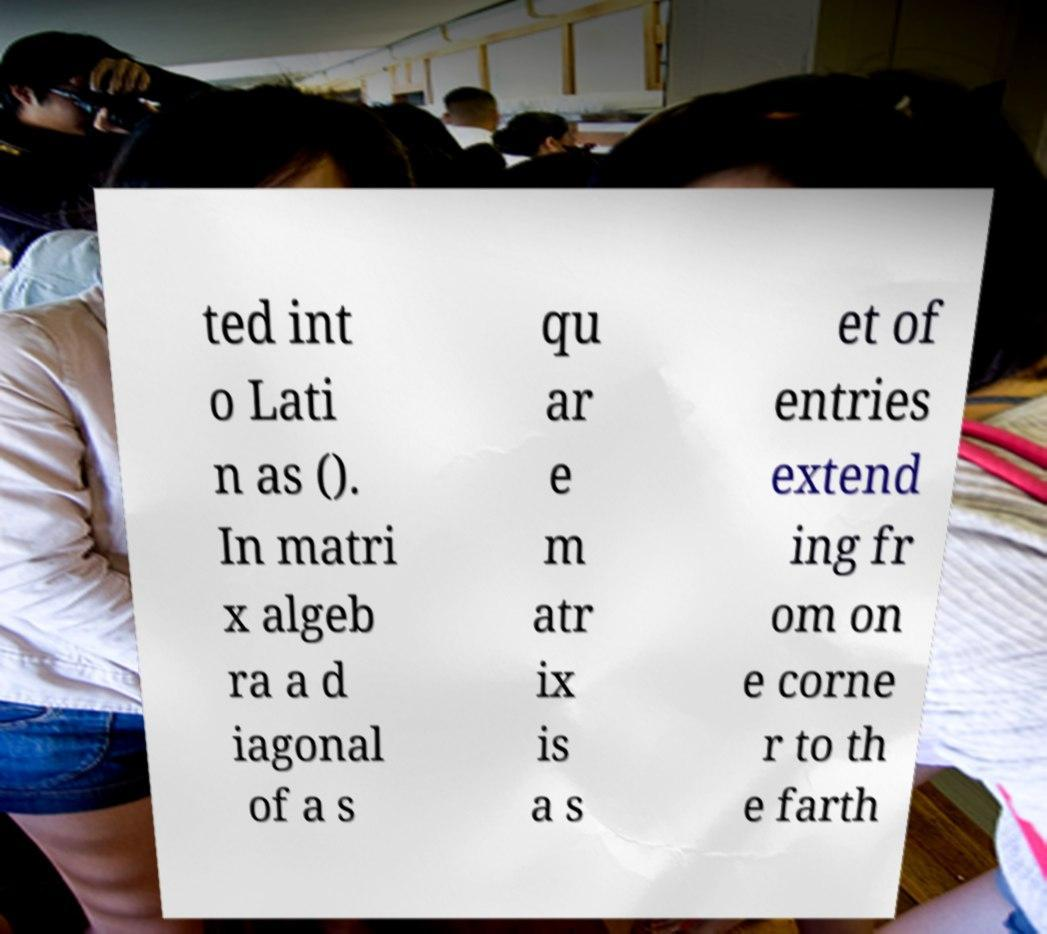Can you read and provide the text displayed in the image?This photo seems to have some interesting text. Can you extract and type it out for me? ted int o Lati n as (). In matri x algeb ra a d iagonal of a s qu ar e m atr ix is a s et of entries extend ing fr om on e corne r to th e farth 